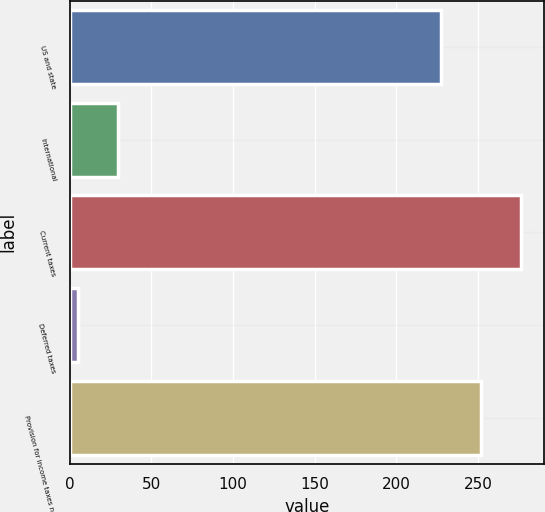<chart> <loc_0><loc_0><loc_500><loc_500><bar_chart><fcel>US and state<fcel>International<fcel>Current taxes<fcel>Deferred taxes<fcel>Provision for income taxes net<nl><fcel>227<fcel>29.7<fcel>276.4<fcel>5<fcel>251.7<nl></chart> 